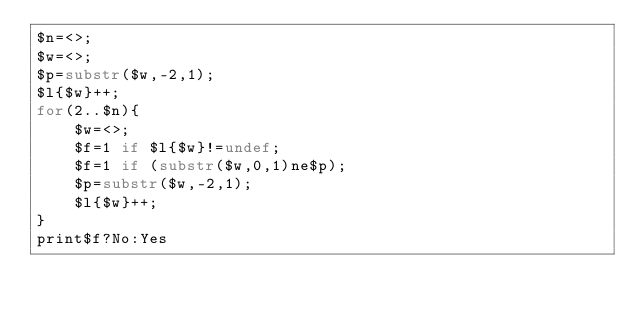Convert code to text. <code><loc_0><loc_0><loc_500><loc_500><_Perl_>$n=<>;
$w=<>;
$p=substr($w,-2,1);
$l{$w}++;
for(2..$n){
    $w=<>;
    $f=1 if $l{$w}!=undef;
    $f=1 if (substr($w,0,1)ne$p);
    $p=substr($w,-2,1);
    $l{$w}++;
}
print$f?No:Yes</code> 